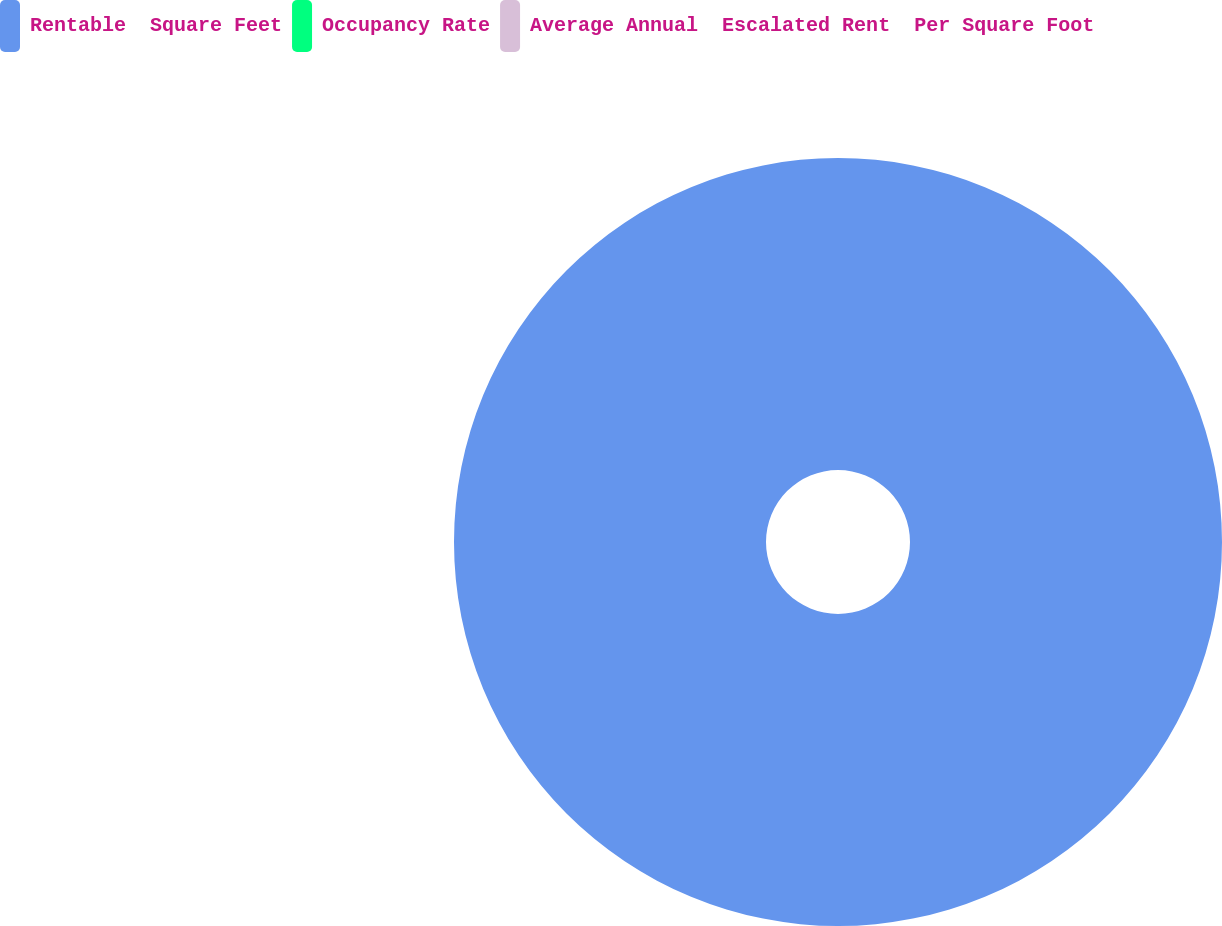Convert chart to OTSL. <chart><loc_0><loc_0><loc_500><loc_500><pie_chart><fcel>Rentable  Square Feet<fcel>Occupancy Rate<fcel>Average Annual  Escalated Rent  Per Square Foot<nl><fcel>100.0%<fcel>0.0%<fcel>0.0%<nl></chart> 